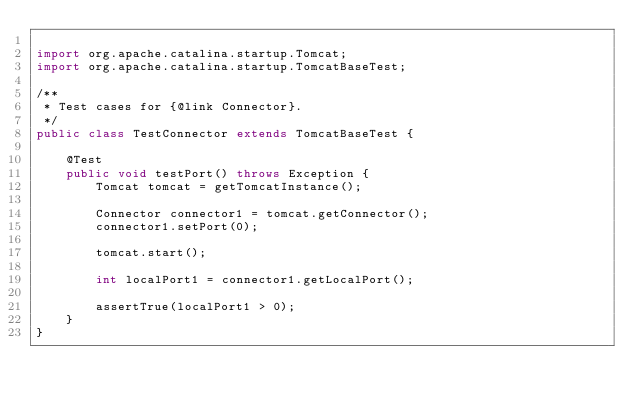<code> <loc_0><loc_0><loc_500><loc_500><_Java_>
import org.apache.catalina.startup.Tomcat;
import org.apache.catalina.startup.TomcatBaseTest;

/**
 * Test cases for {@link Connector}.
 */
public class TestConnector extends TomcatBaseTest {

    @Test
    public void testPort() throws Exception {
        Tomcat tomcat = getTomcatInstance();

        Connector connector1 = tomcat.getConnector();
        connector1.setPort(0);

        tomcat.start();

        int localPort1 = connector1.getLocalPort();

        assertTrue(localPort1 > 0);
    }
}
</code> 